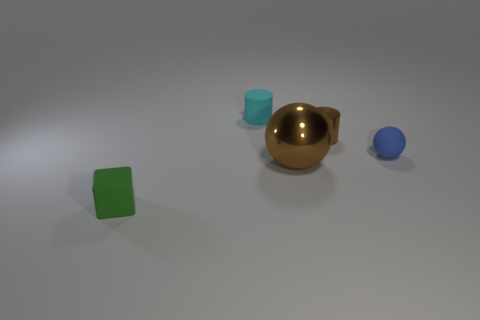Are there any green cubes in front of the big ball?
Offer a very short reply. Yes. There is a matte object that is behind the small brown metallic cylinder; does it have the same shape as the brown thing in front of the small blue object?
Keep it short and to the point. No. There is another thing that is the same shape as the small metallic thing; what is it made of?
Make the answer very short. Rubber. What number of blocks are either small things or rubber objects?
Your answer should be compact. 1. What number of large brown spheres are made of the same material as the brown cylinder?
Ensure brevity in your answer.  1. Do the tiny cylinder that is behind the tiny brown shiny cylinder and the sphere in front of the small blue rubber sphere have the same material?
Give a very brief answer. No. There is a cube that is left of the shiny object behind the big metal thing; how many tiny brown metal cylinders are right of it?
Offer a very short reply. 1. There is a small thing that is in front of the brown metal ball; is its color the same as the matte thing that is behind the blue rubber sphere?
Provide a succinct answer. No. Is there anything else that is the same color as the big object?
Offer a very short reply. Yes. There is a tiny object left of the cyan thing to the left of the blue rubber thing; what is its color?
Ensure brevity in your answer.  Green. 